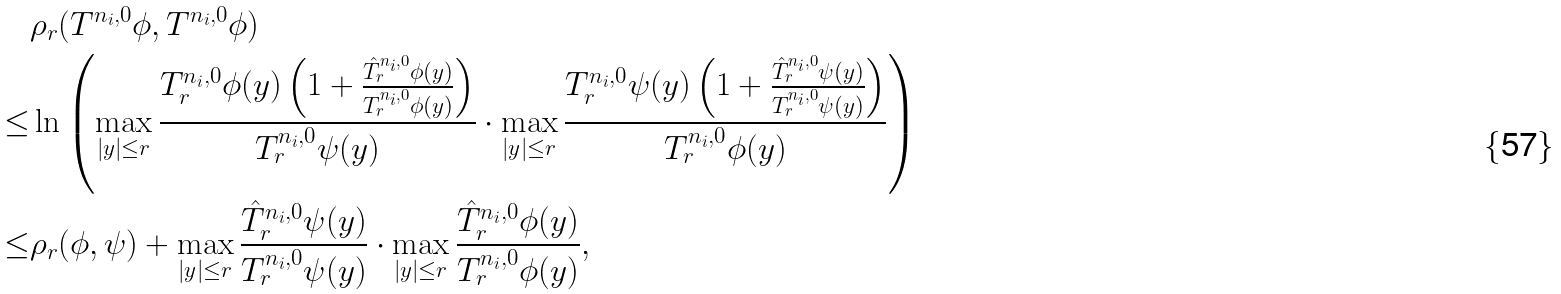Convert formula to latex. <formula><loc_0><loc_0><loc_500><loc_500>& \rho _ { r } ( T ^ { n _ { i } , 0 } \phi , T ^ { n _ { i } , 0 } \phi ) \\ \leq & \ln \left ( \max _ { | y | \leq r } \frac { T _ { r } ^ { n _ { i } , 0 } \phi ( y ) \left ( 1 + \frac { \hat { T } _ { r } ^ { n _ { i } , 0 } \phi ( y ) } { T _ { r } ^ { n _ { i } , 0 } \phi ( y ) } \right ) } { T _ { r } ^ { n _ { i } , 0 } \psi ( y ) } \cdot \max _ { | y | \leq r } \frac { T _ { r } ^ { n _ { i } , 0 } \psi ( y ) \left ( 1 + \frac { \hat { T } _ { r } ^ { n _ { i } , 0 } \psi ( y ) } { T _ { r } ^ { n _ { i } , 0 } \psi ( y ) } \right ) } { T _ { r } ^ { n _ { i } , 0 } \phi ( y ) } \right ) \\ \leq & \rho _ { r } ( \phi , \psi ) + \max _ { | y | \leq r } \frac { \hat { T } _ { r } ^ { n _ { i } , 0 } \psi ( y ) } { T _ { r } ^ { n _ { i } , 0 } \psi ( y ) } \cdot \max _ { | y | \leq r } \frac { \hat { T } _ { r } ^ { n _ { i } , 0 } \phi ( y ) } { T _ { r } ^ { n _ { i } , 0 } \phi ( y ) } ,</formula> 